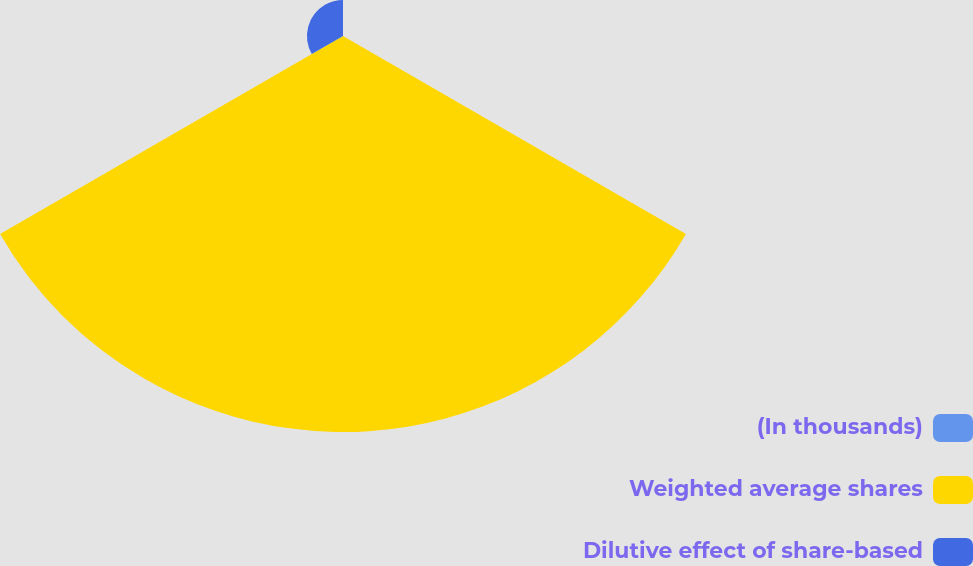Convert chart. <chart><loc_0><loc_0><loc_500><loc_500><pie_chart><fcel>(In thousands)<fcel>Weighted average shares<fcel>Dilutive effect of share-based<nl><fcel>0.0%<fcel>91.65%<fcel>8.34%<nl></chart> 